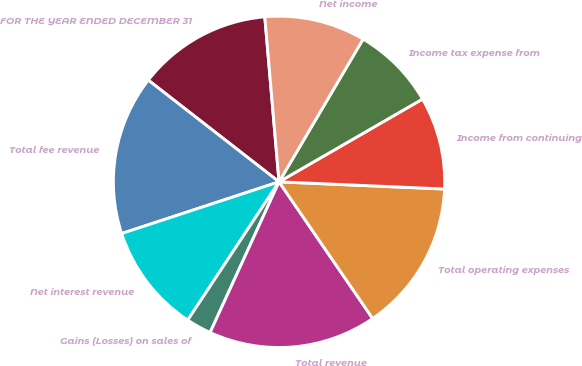<chart> <loc_0><loc_0><loc_500><loc_500><pie_chart><fcel>FOR THE YEAR ENDED DECEMBER 31<fcel>Total fee revenue<fcel>Net interest revenue<fcel>Gains (Losses) on sales of<fcel>Total revenue<fcel>Total operating expenses<fcel>Income from continuing<fcel>Income tax expense from<fcel>Net income<nl><fcel>13.11%<fcel>15.57%<fcel>10.66%<fcel>2.46%<fcel>16.39%<fcel>14.75%<fcel>9.02%<fcel>8.2%<fcel>9.84%<nl></chart> 